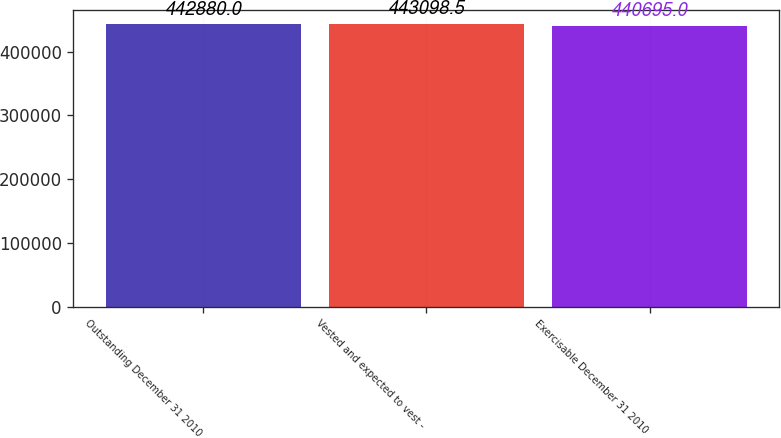Convert chart to OTSL. <chart><loc_0><loc_0><loc_500><loc_500><bar_chart><fcel>Outstanding December 31 2010<fcel>Vested and expected to vest -<fcel>Exercisable December 31 2010<nl><fcel>442880<fcel>443098<fcel>440695<nl></chart> 